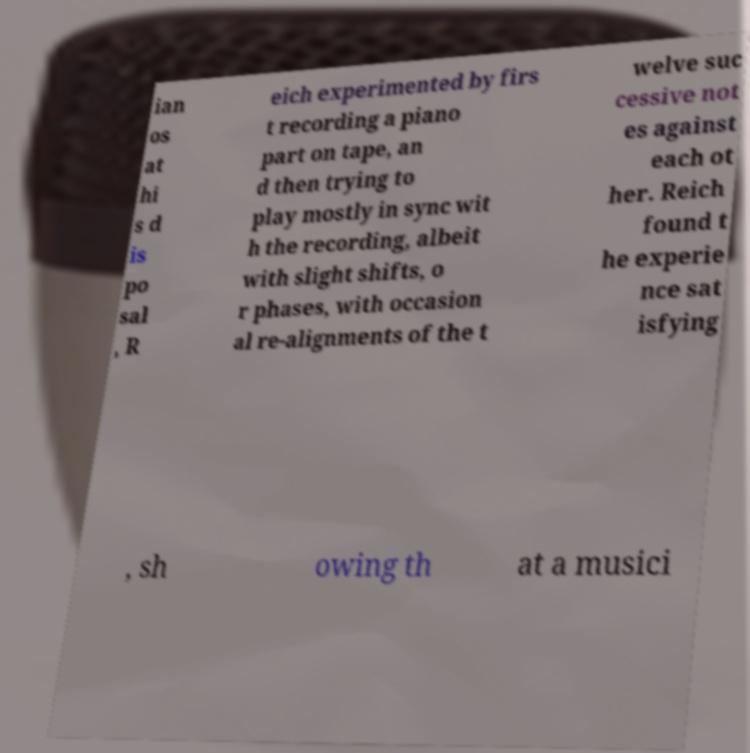Could you extract and type out the text from this image? ian os at hi s d is po sal , R eich experimented by firs t recording a piano part on tape, an d then trying to play mostly in sync wit h the recording, albeit with slight shifts, o r phases, with occasion al re-alignments of the t welve suc cessive not es against each ot her. Reich found t he experie nce sat isfying , sh owing th at a musici 